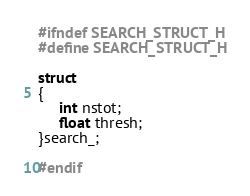<code> <loc_0><loc_0><loc_500><loc_500><_C_>#ifndef SEARCH_STRUCT_H
#define SEARCH_STRUCT_H

struct
{
     int nstot;
     float thresh;
}search_;

#endif
</code> 